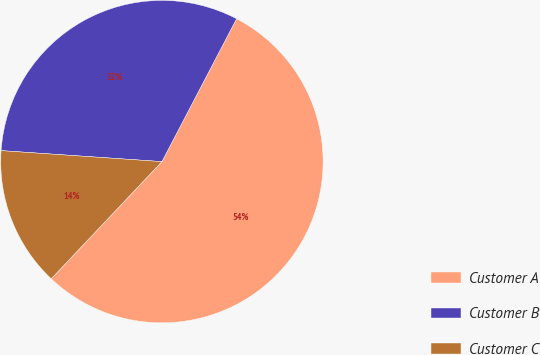<chart> <loc_0><loc_0><loc_500><loc_500><pie_chart><fcel>Customer A<fcel>Customer B<fcel>Customer C<nl><fcel>54.39%<fcel>31.58%<fcel>14.04%<nl></chart> 